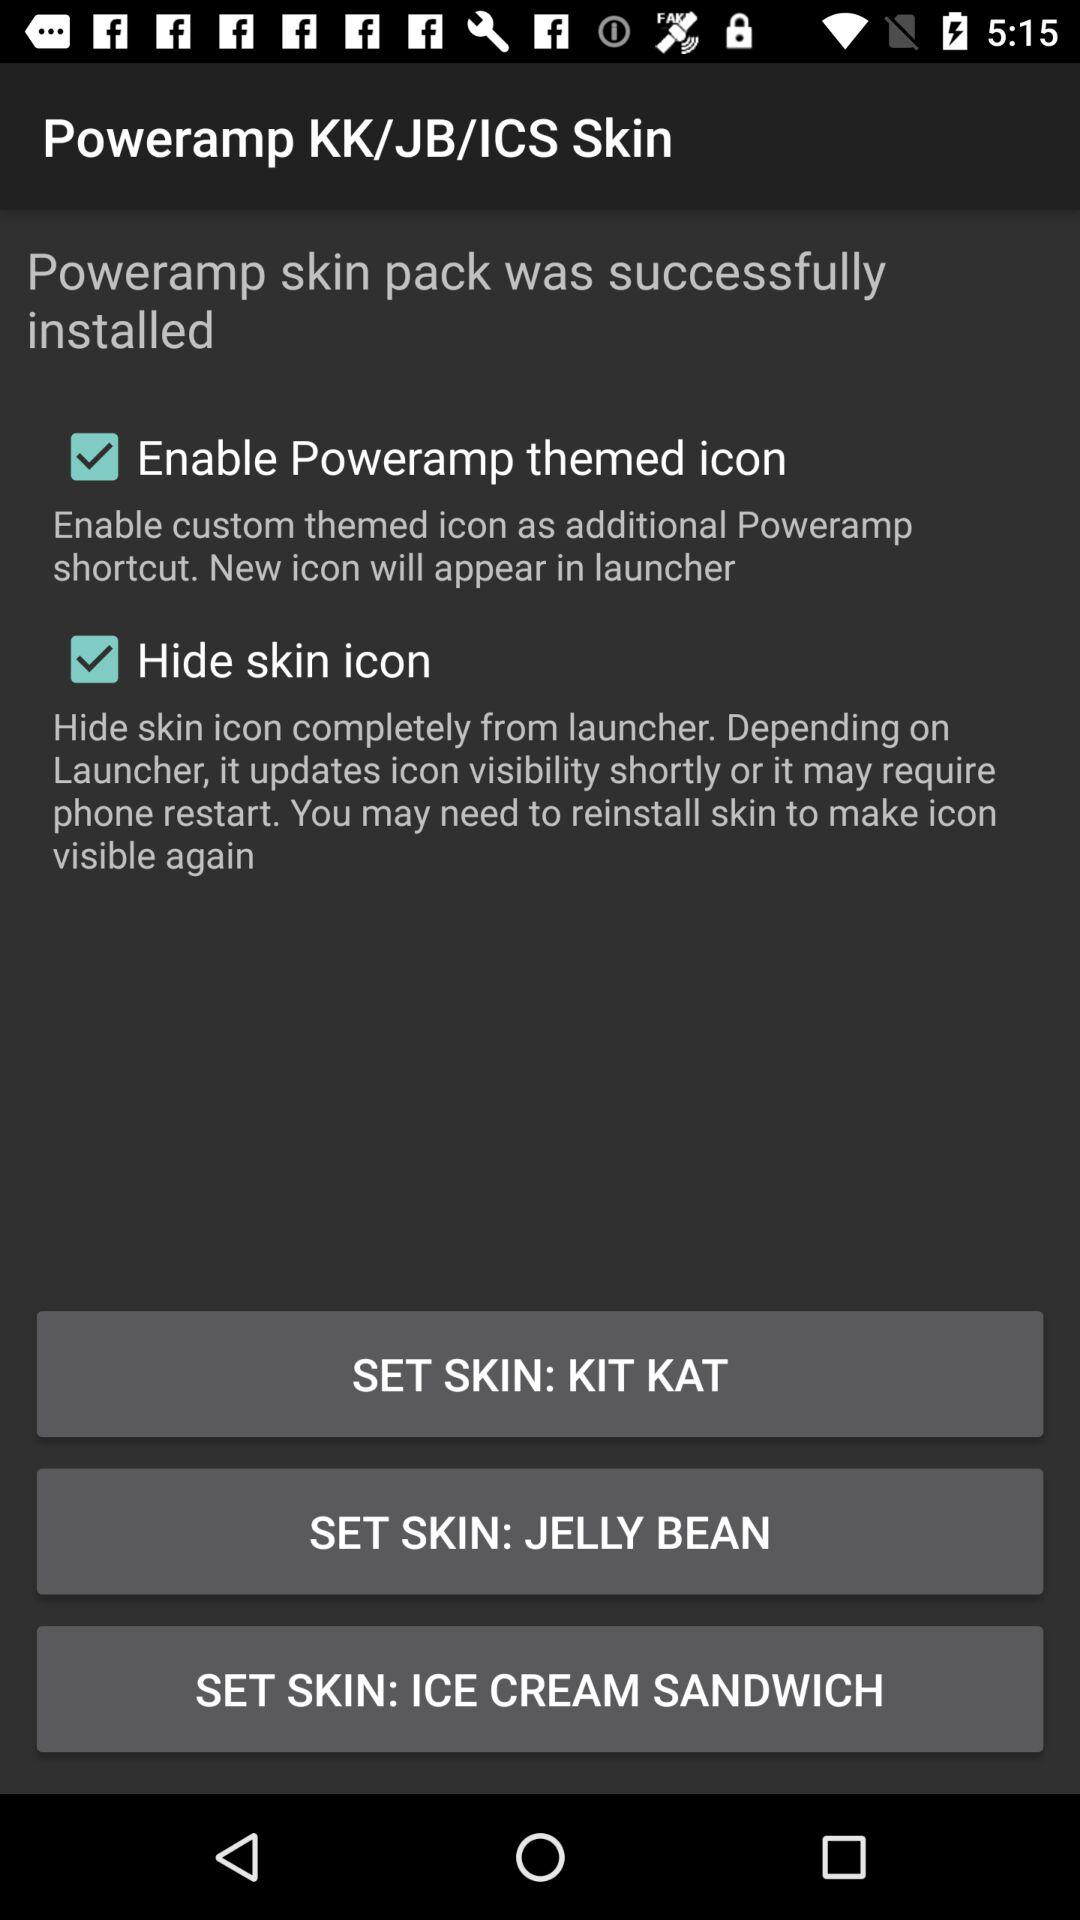How many skins are available for this app?
Answer the question using a single word or phrase. 3 